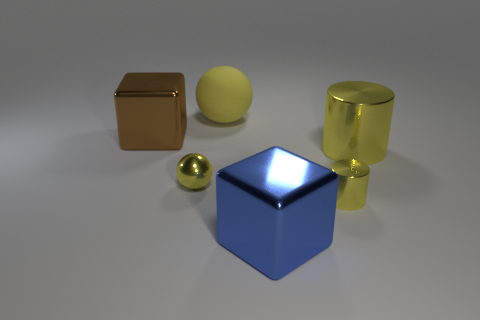Subtract all blue cylinders. Subtract all brown cubes. How many cylinders are left? 2 Add 2 blue blocks. How many objects exist? 8 Subtract all cubes. How many objects are left? 4 Add 1 small yellow shiny things. How many small yellow shiny things are left? 3 Add 1 blocks. How many blocks exist? 3 Subtract 0 green spheres. How many objects are left? 6 Subtract all small cylinders. Subtract all large blue shiny objects. How many objects are left? 4 